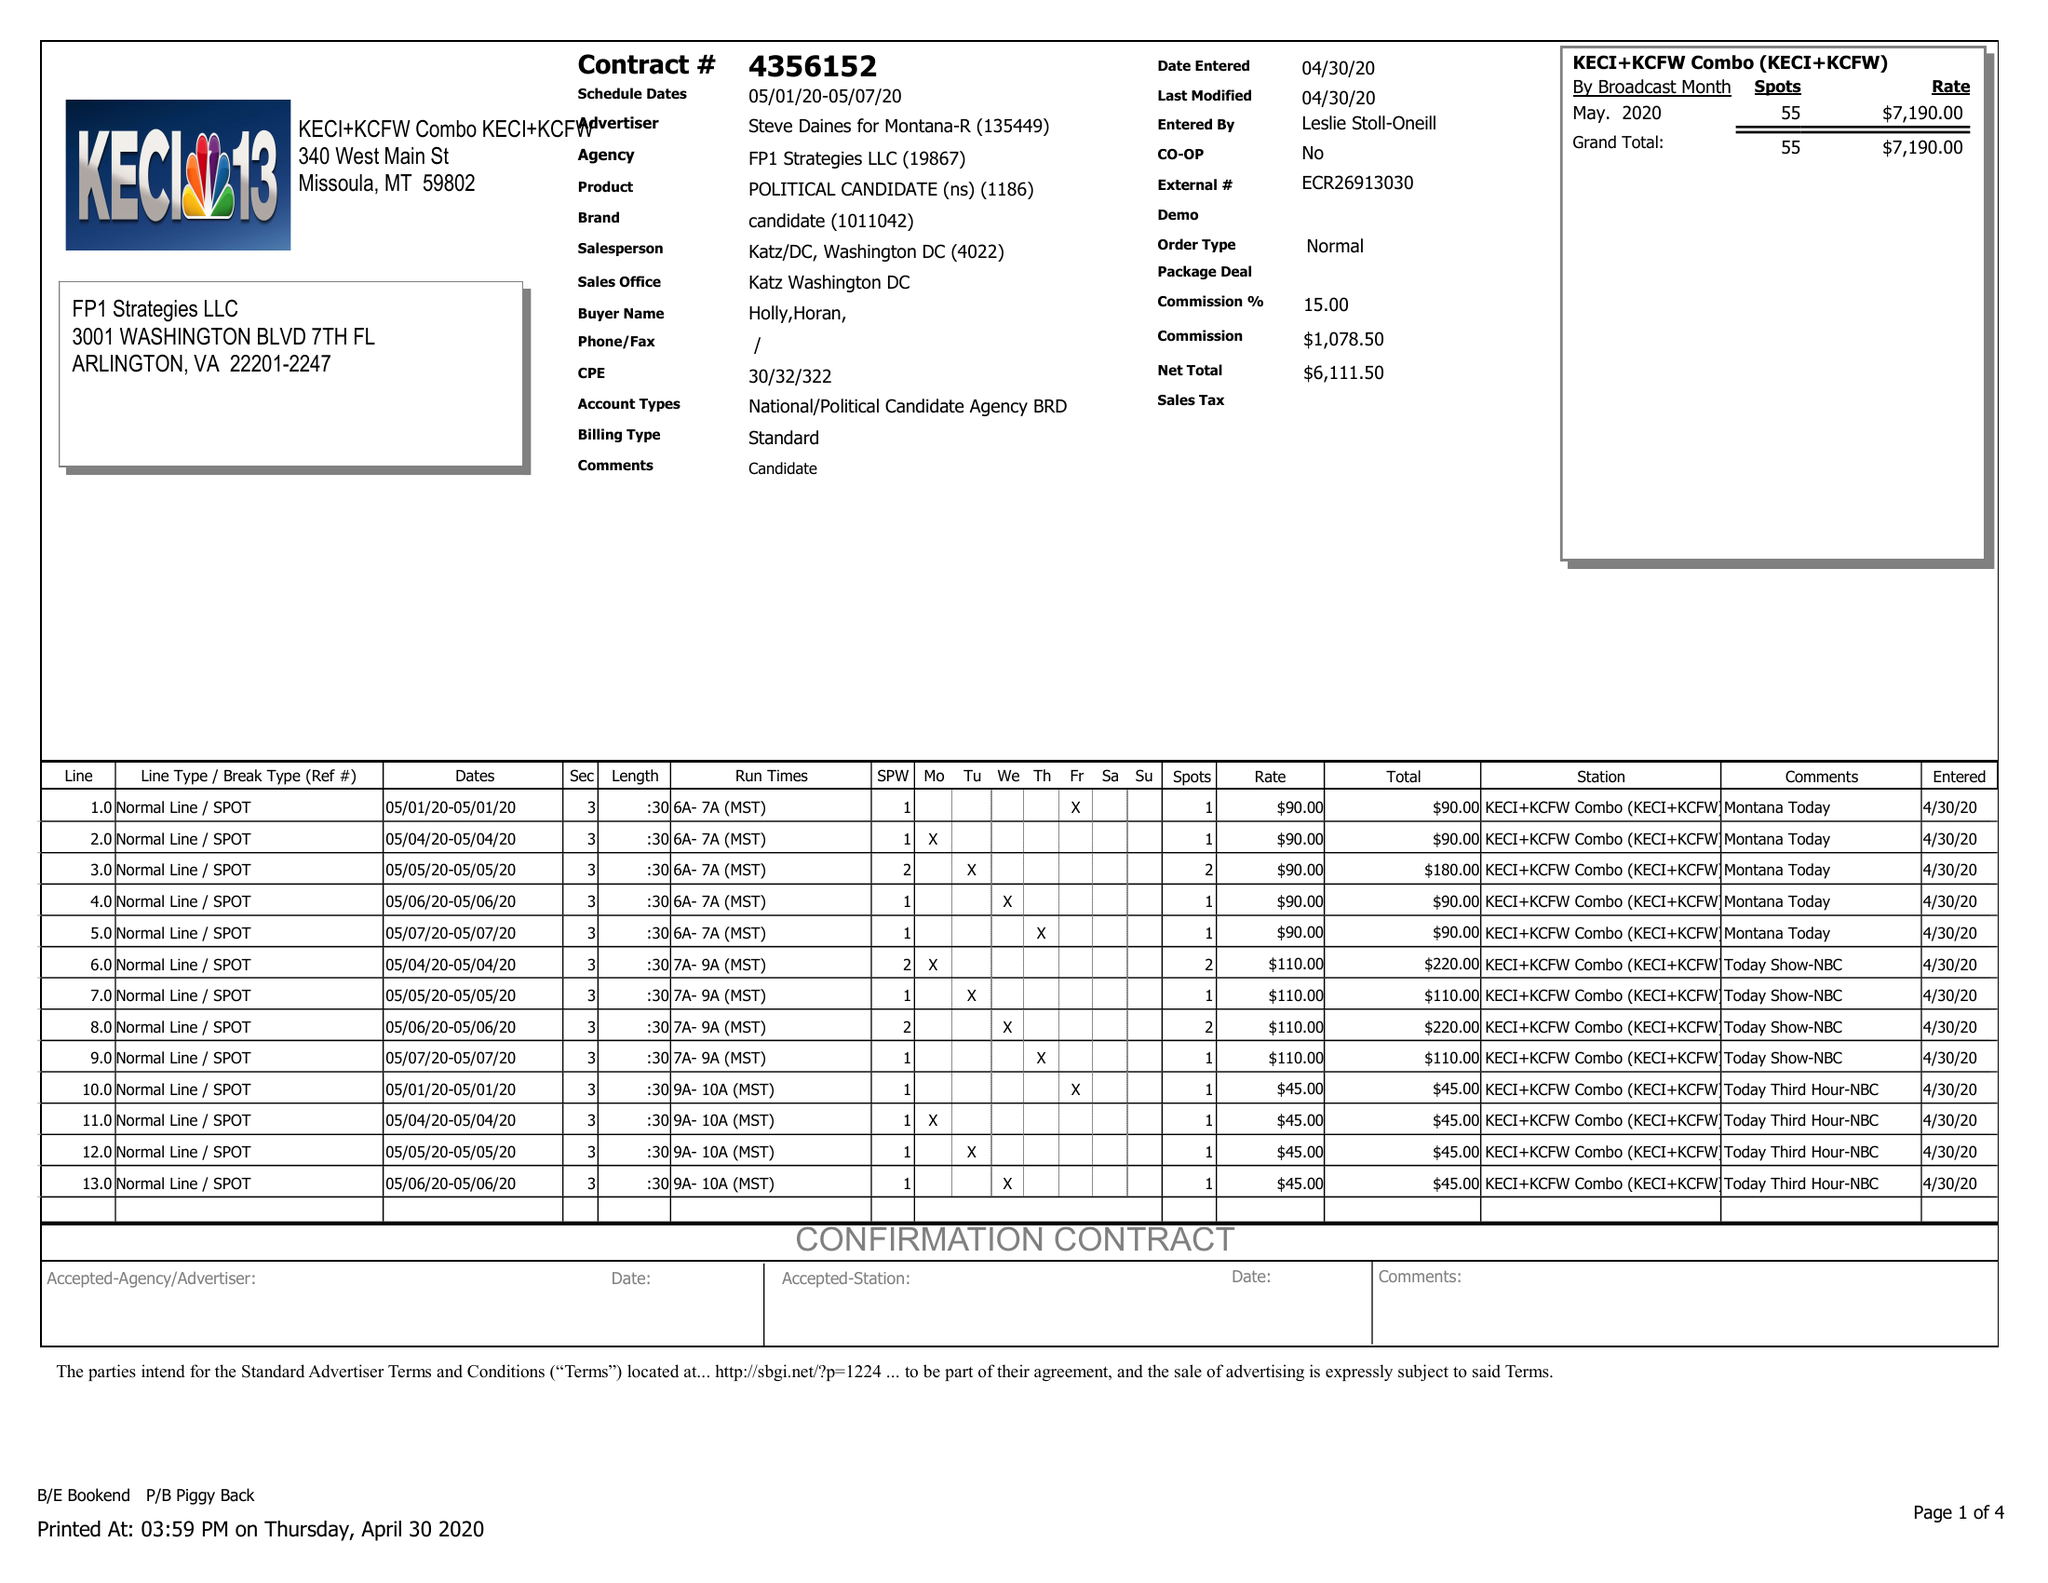What is the value for the gross_amount?
Answer the question using a single word or phrase. 7190.00 